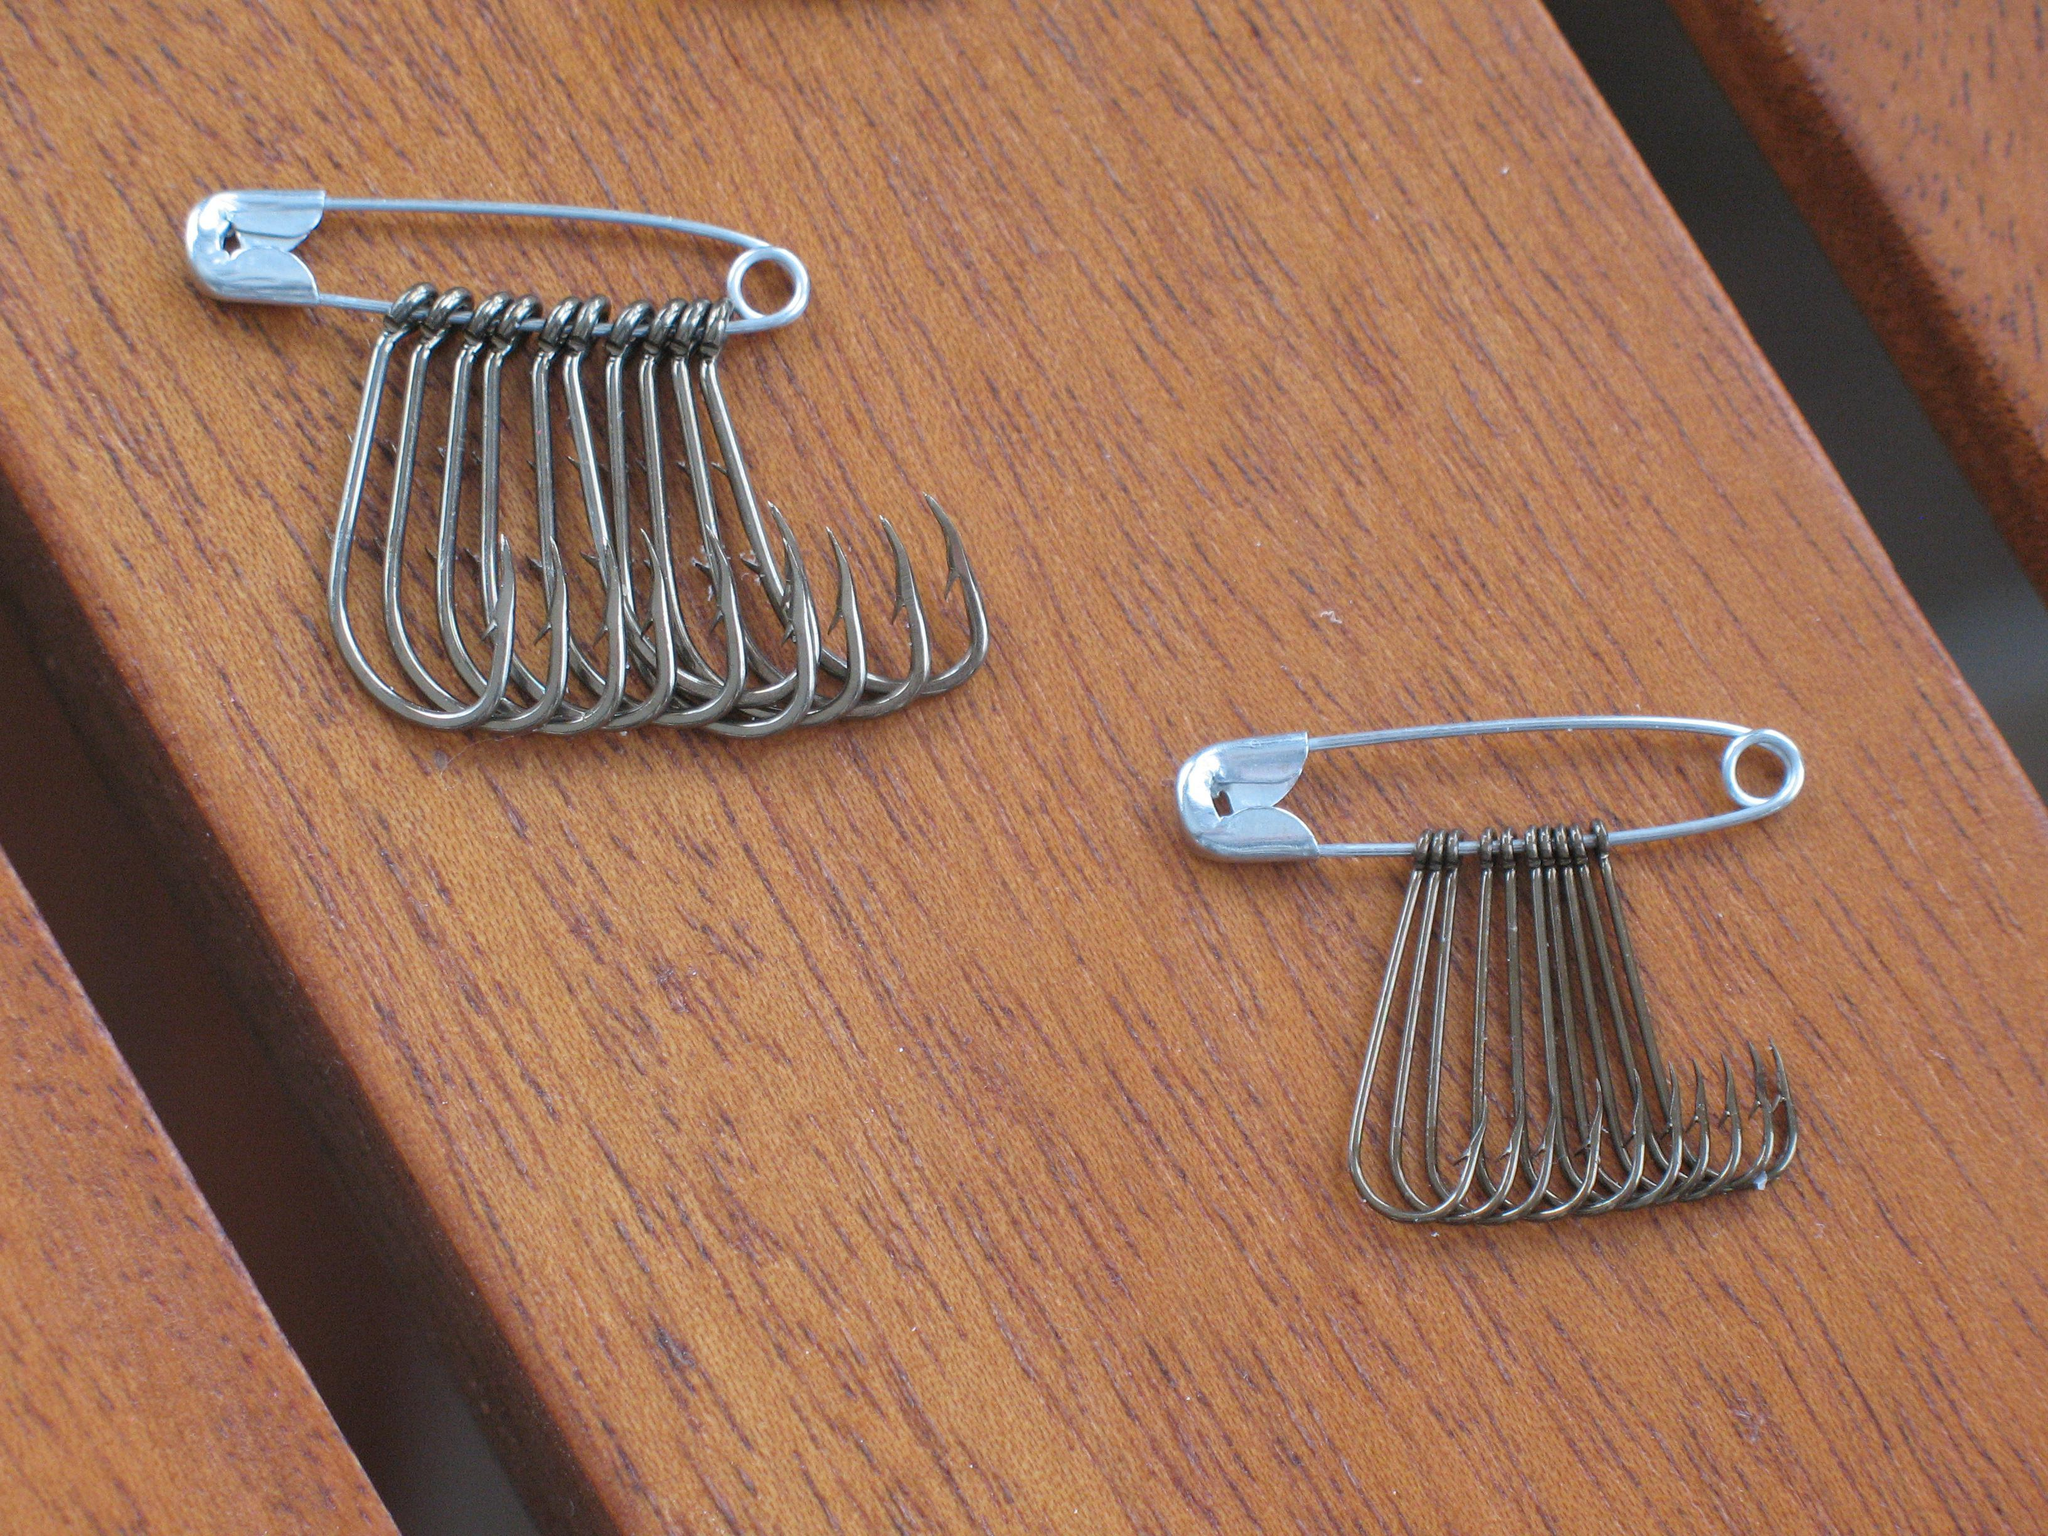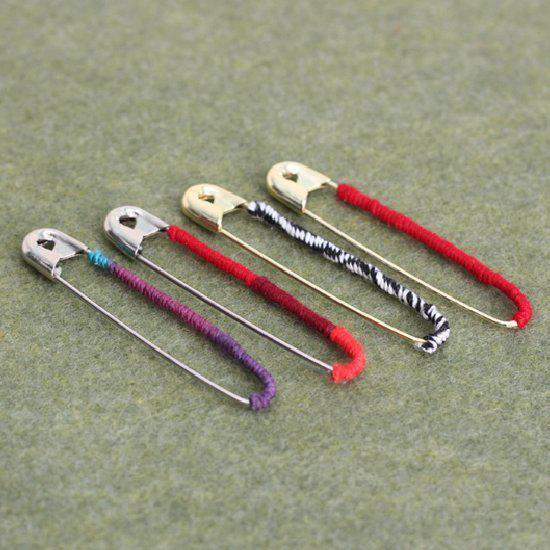The first image is the image on the left, the second image is the image on the right. For the images displayed, is the sentence "Left and right images show a decorative item resembling an indian headdress, and at least one of the items is made with blue beads strung on safety pins." factually correct? Answer yes or no. No. The first image is the image on the left, the second image is the image on the right. For the images shown, is this caption "Exactly one of the images contains feathers." true? Answer yes or no. No. 